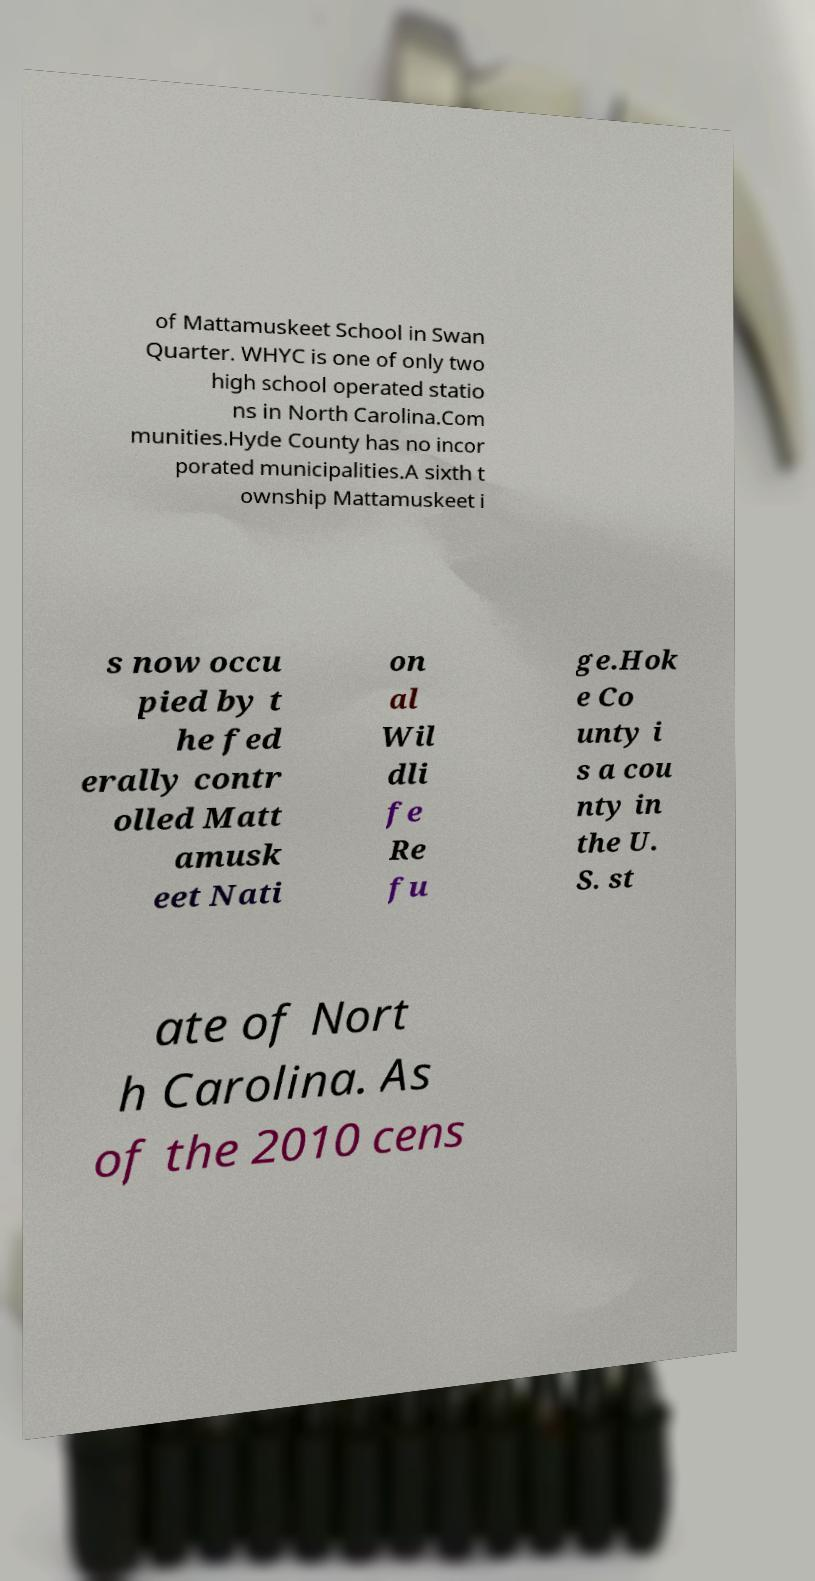Could you assist in decoding the text presented in this image and type it out clearly? of Mattamuskeet School in Swan Quarter. WHYC is one of only two high school operated statio ns in North Carolina.Com munities.Hyde County has no incor porated municipalities.A sixth t ownship Mattamuskeet i s now occu pied by t he fed erally contr olled Matt amusk eet Nati on al Wil dli fe Re fu ge.Hok e Co unty i s a cou nty in the U. S. st ate of Nort h Carolina. As of the 2010 cens 